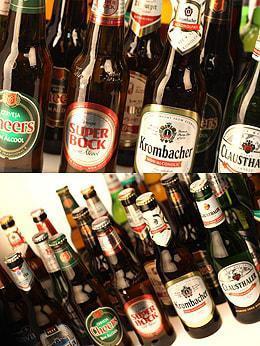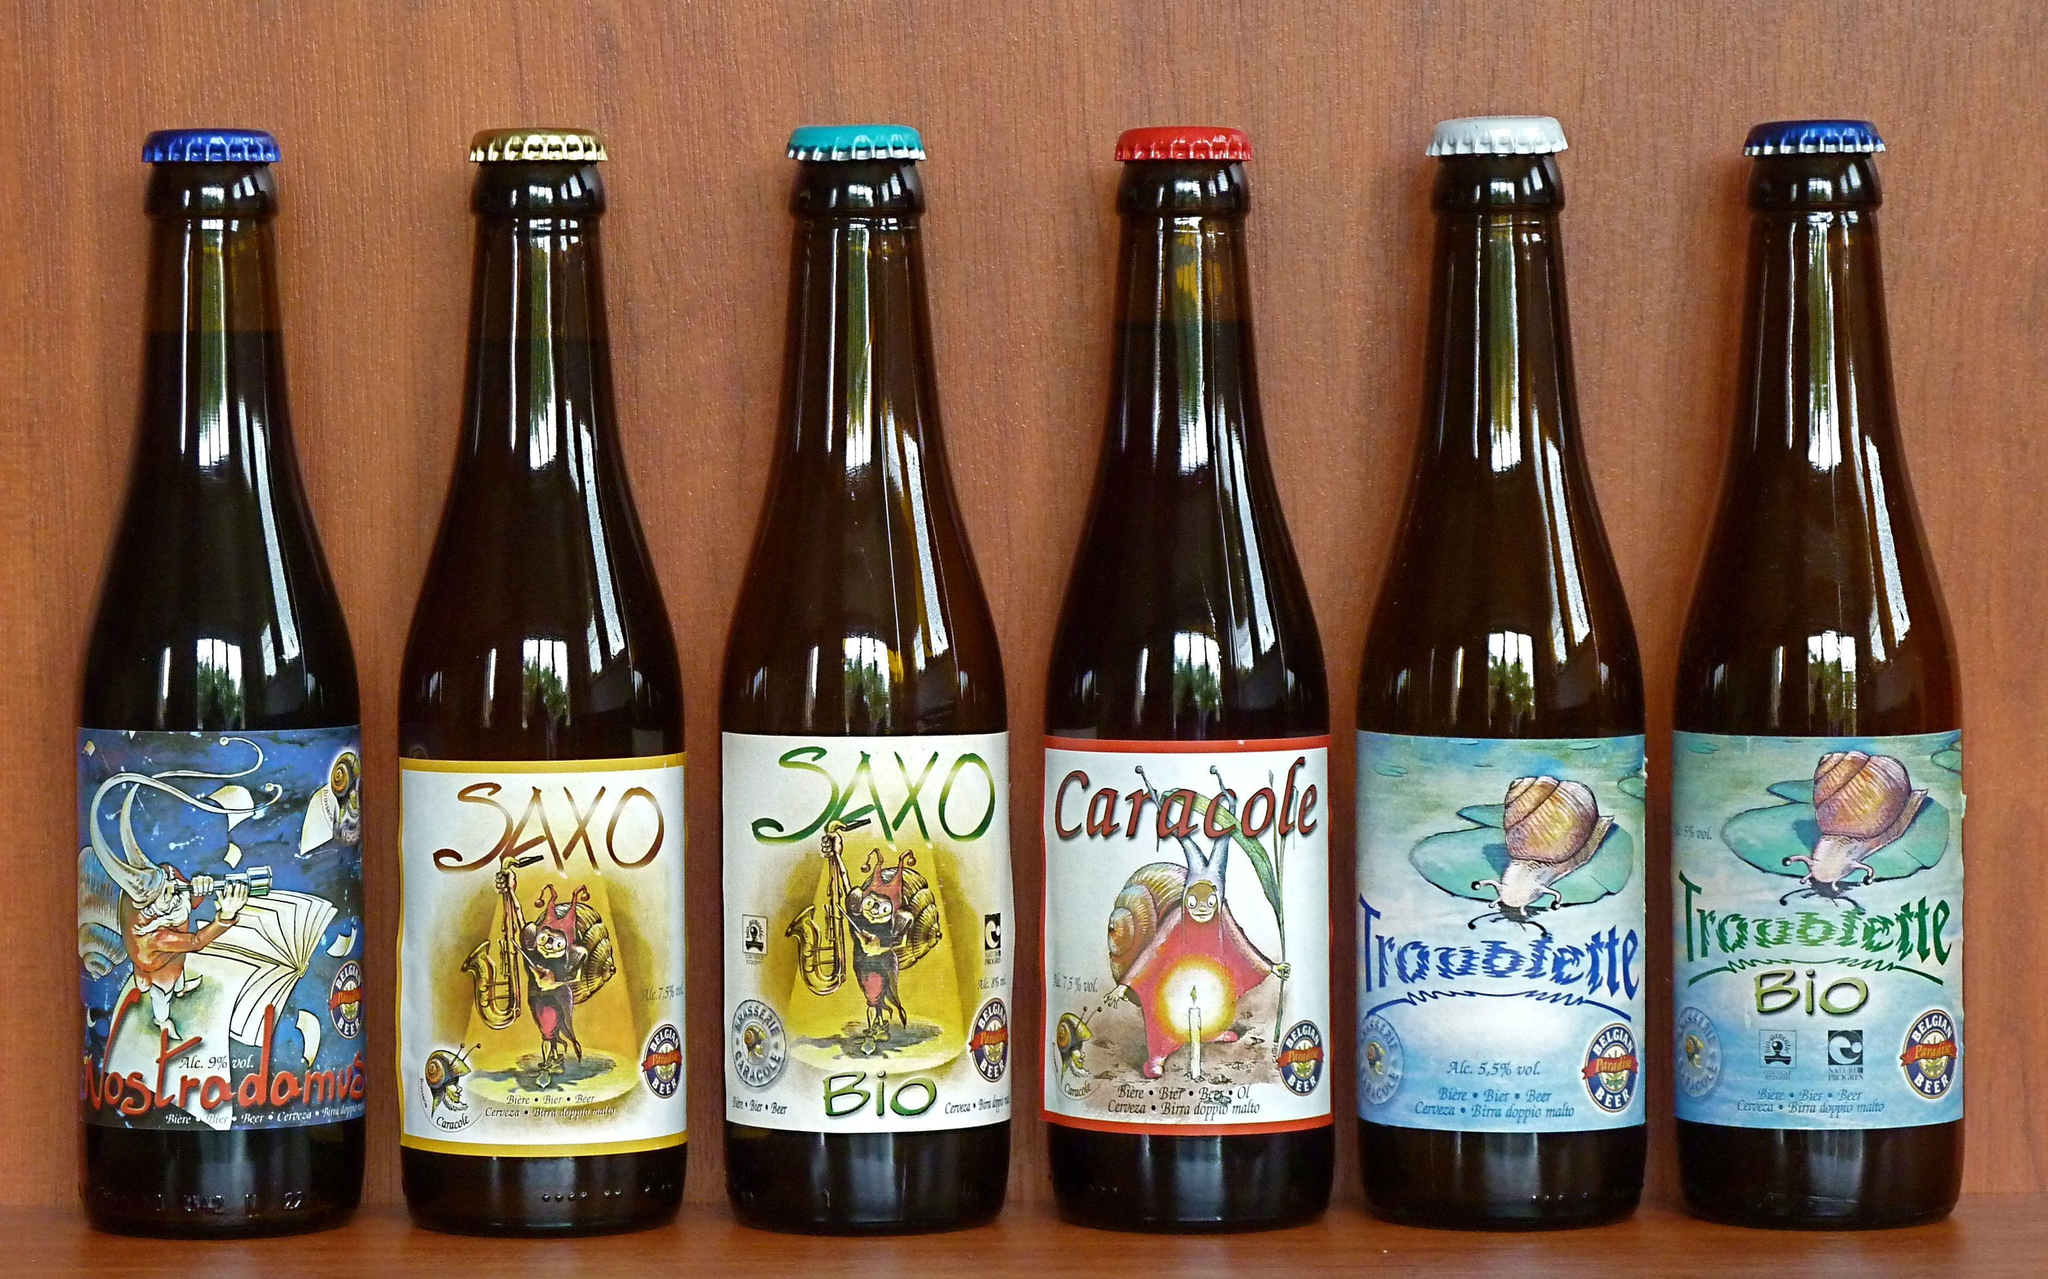The first image is the image on the left, the second image is the image on the right. For the images displayed, is the sentence "One of the images includes fewer than eight bottles in total." factually correct? Answer yes or no. Yes. 